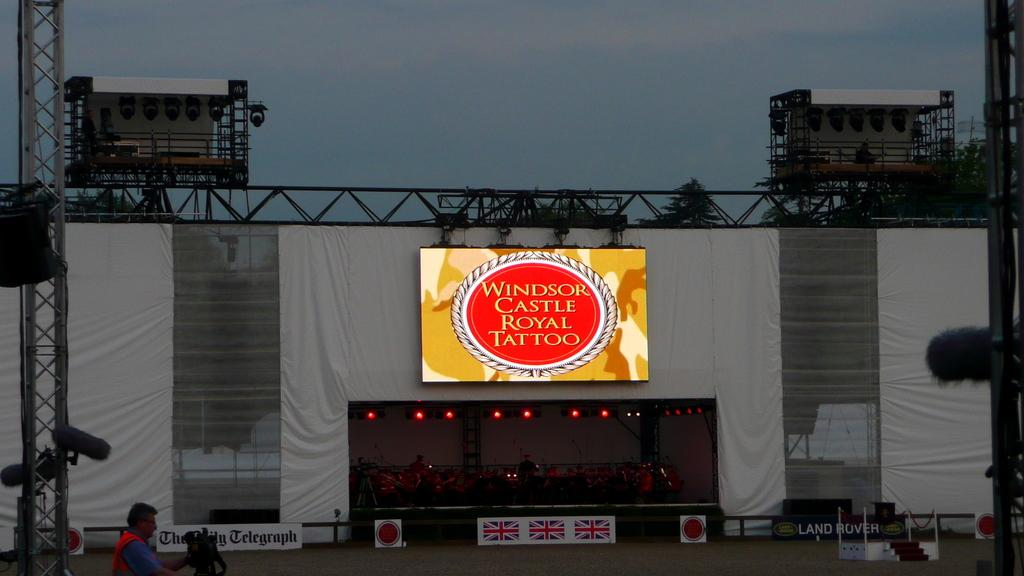<image>
Describe the image concisely. A music stage with a sign that says "Windsor Castle Royal Tattoo" 